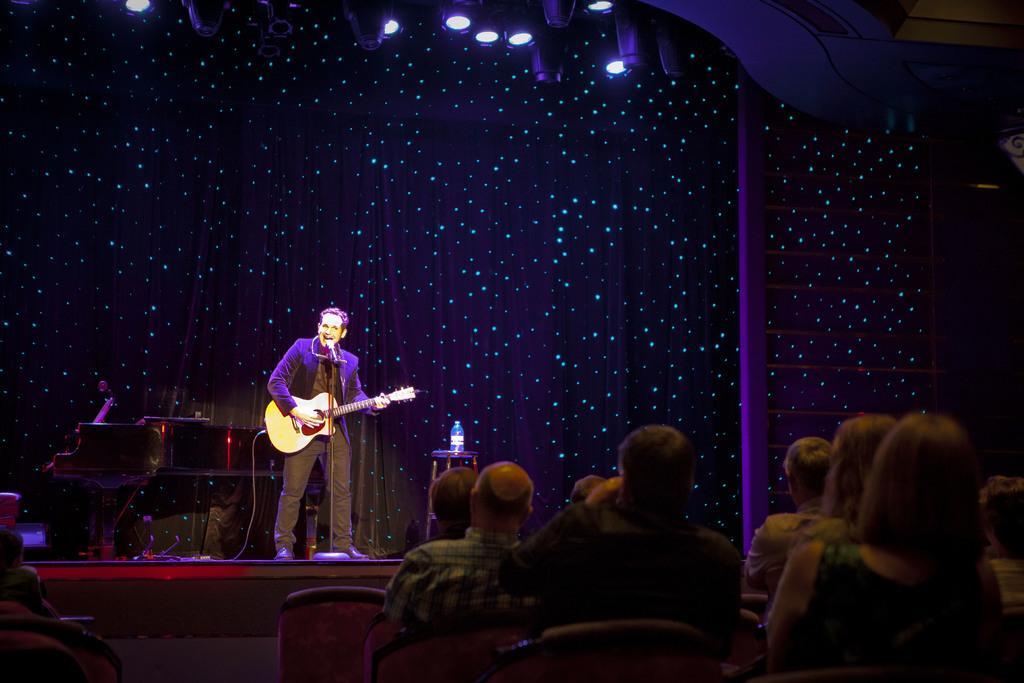Could you give a brief overview of what you see in this image? In this image there is a man standing and playing a guitar and singing a song in the microphone and the back ground there is piano, chair, bottle, group of people sitting in chair, lights. 